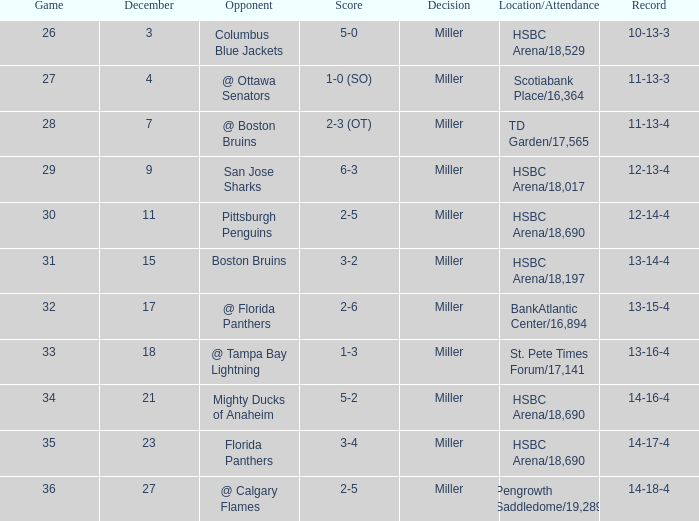Name the december for record 14-17-4 23.0. 